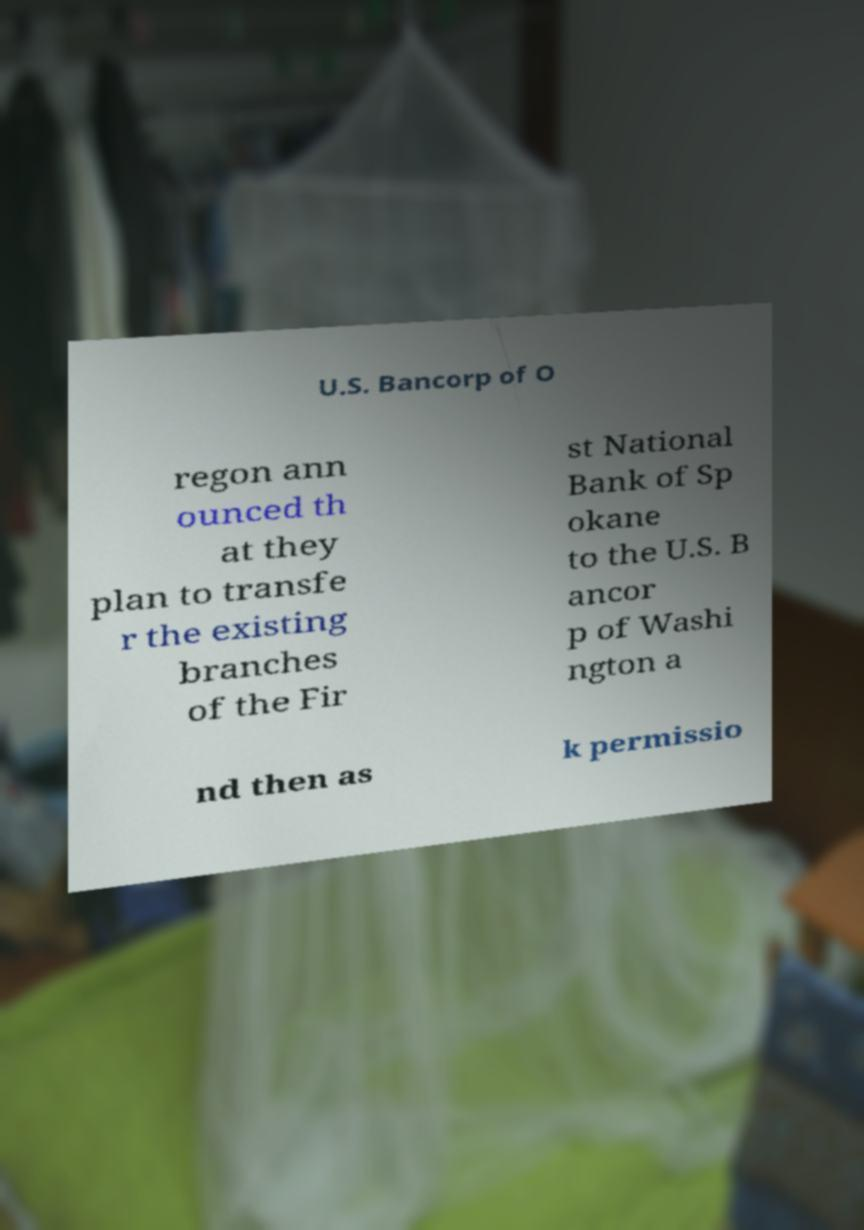Please read and relay the text visible in this image. What does it say? U.S. Bancorp of O regon ann ounced th at they plan to transfe r the existing branches of the Fir st National Bank of Sp okane to the U.S. B ancor p of Washi ngton a nd then as k permissio 